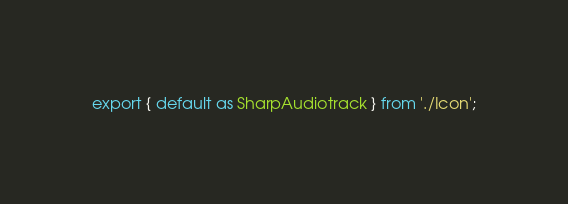Convert code to text. <code><loc_0><loc_0><loc_500><loc_500><_TypeScript_>export { default as SharpAudiotrack } from './Icon';
</code> 